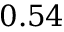Convert formula to latex. <formula><loc_0><loc_0><loc_500><loc_500>0 . 5 4</formula> 